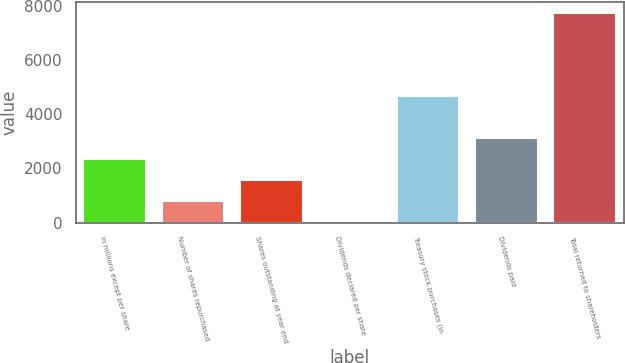Convert chart to OTSL. <chart><loc_0><loc_0><loc_500><loc_500><bar_chart><fcel>In millions except per share<fcel>Number of shares repurchased<fcel>Shares outstanding at year end<fcel>Dividends declared per share<fcel>Treasury stock purchases (in<fcel>Dividends paid<fcel>Total returned to shareholders<nl><fcel>2324.69<fcel>777.45<fcel>1551.07<fcel>3.83<fcel>4651<fcel>3098.31<fcel>7740<nl></chart> 